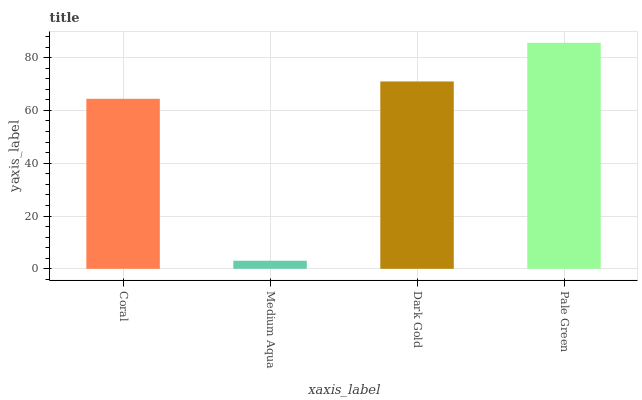Is Medium Aqua the minimum?
Answer yes or no. Yes. Is Pale Green the maximum?
Answer yes or no. Yes. Is Dark Gold the minimum?
Answer yes or no. No. Is Dark Gold the maximum?
Answer yes or no. No. Is Dark Gold greater than Medium Aqua?
Answer yes or no. Yes. Is Medium Aqua less than Dark Gold?
Answer yes or no. Yes. Is Medium Aqua greater than Dark Gold?
Answer yes or no. No. Is Dark Gold less than Medium Aqua?
Answer yes or no. No. Is Dark Gold the high median?
Answer yes or no. Yes. Is Coral the low median?
Answer yes or no. Yes. Is Coral the high median?
Answer yes or no. No. Is Dark Gold the low median?
Answer yes or no. No. 